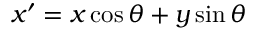Convert formula to latex. <formula><loc_0><loc_0><loc_500><loc_500>x ^ { \prime } = x \cos \theta + y \sin \theta</formula> 